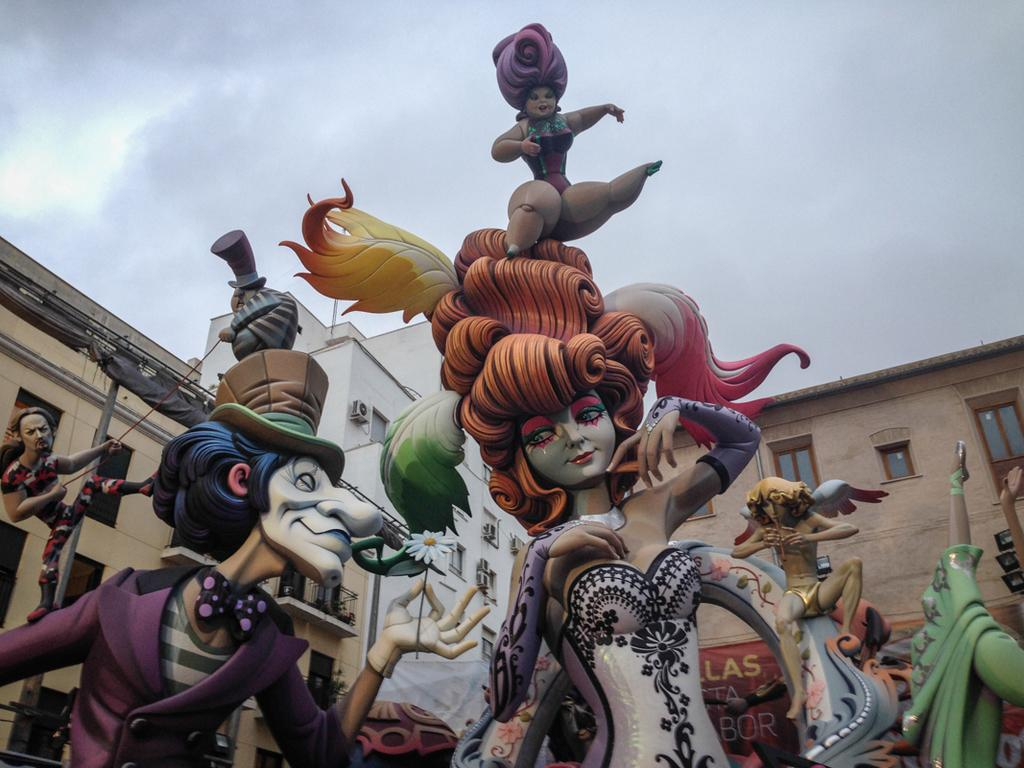What type of art is featured in the image? The image contains digital art. Can you describe the subjects in the image? There are people standing in the image. What type of structures are visible in the image? There are buildings in the image. What can be seen in the background of the image? The sky is visible in the background of the image. What type of horn can be heard in the image? There is no sound or horn present in the image, as it is a still digital art piece. What type of destruction can be seen in the image? There is no destruction present in the image; it features people standing and buildings. 